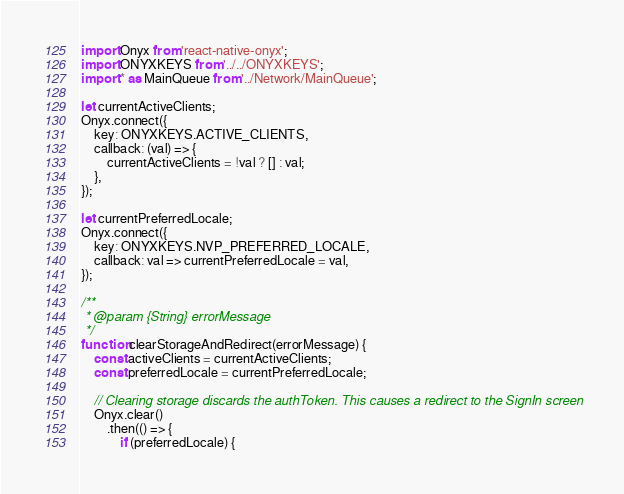Convert code to text. <code><loc_0><loc_0><loc_500><loc_500><_JavaScript_>import Onyx from 'react-native-onyx';
import ONYXKEYS from '../../ONYXKEYS';
import * as MainQueue from '../Network/MainQueue';

let currentActiveClients;
Onyx.connect({
    key: ONYXKEYS.ACTIVE_CLIENTS,
    callback: (val) => {
        currentActiveClients = !val ? [] : val;
    },
});

let currentPreferredLocale;
Onyx.connect({
    key: ONYXKEYS.NVP_PREFERRED_LOCALE,
    callback: val => currentPreferredLocale = val,
});

/**
 * @param {String} errorMessage
 */
function clearStorageAndRedirect(errorMessage) {
    const activeClients = currentActiveClients;
    const preferredLocale = currentPreferredLocale;

    // Clearing storage discards the authToken. This causes a redirect to the SignIn screen
    Onyx.clear()
        .then(() => {
            if (preferredLocale) {</code> 